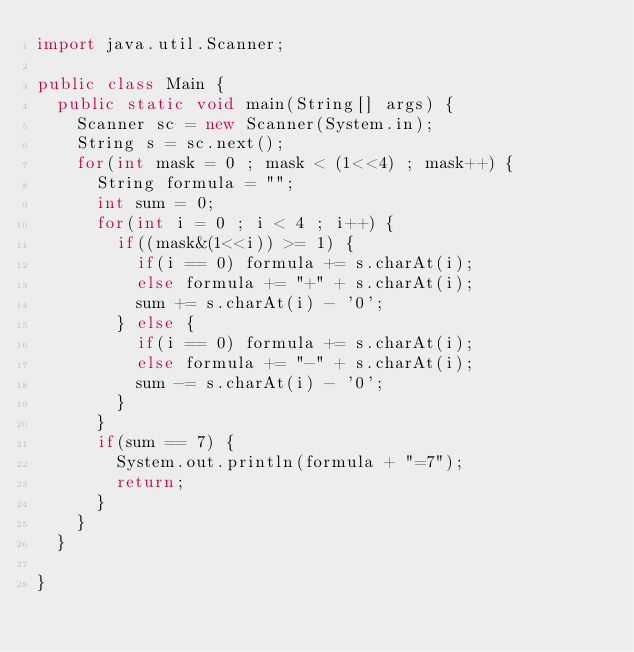Convert code to text. <code><loc_0><loc_0><loc_500><loc_500><_Java_>import java.util.Scanner;

public class Main {
	public static void main(String[] args) {
		Scanner sc = new Scanner(System.in);
		String s = sc.next();
		for(int mask = 0 ; mask < (1<<4) ; mask++) {
			String formula = "";
			int sum = 0;
			for(int i = 0 ; i < 4 ; i++) {
				if((mask&(1<<i)) >= 1) {
					if(i == 0) formula += s.charAt(i);
					else formula += "+" + s.charAt(i);
					sum += s.charAt(i) - '0';
				} else {
					if(i == 0) formula += s.charAt(i);
					else formula += "-" + s.charAt(i);
					sum -= s.charAt(i) - '0';
				}
			}
			if(sum == 7) {
				System.out.println(formula + "=7");
				return;
			}
		}
	}

}
</code> 